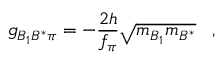Convert formula to latex. <formula><loc_0><loc_0><loc_500><loc_500>g _ { B _ { 1 } B ^ { * } \pi } = - { \frac { 2 h } { f _ { \pi } } } \sqrt { m _ { B _ { 1 } } m _ { B ^ { * } } } \, ,</formula> 